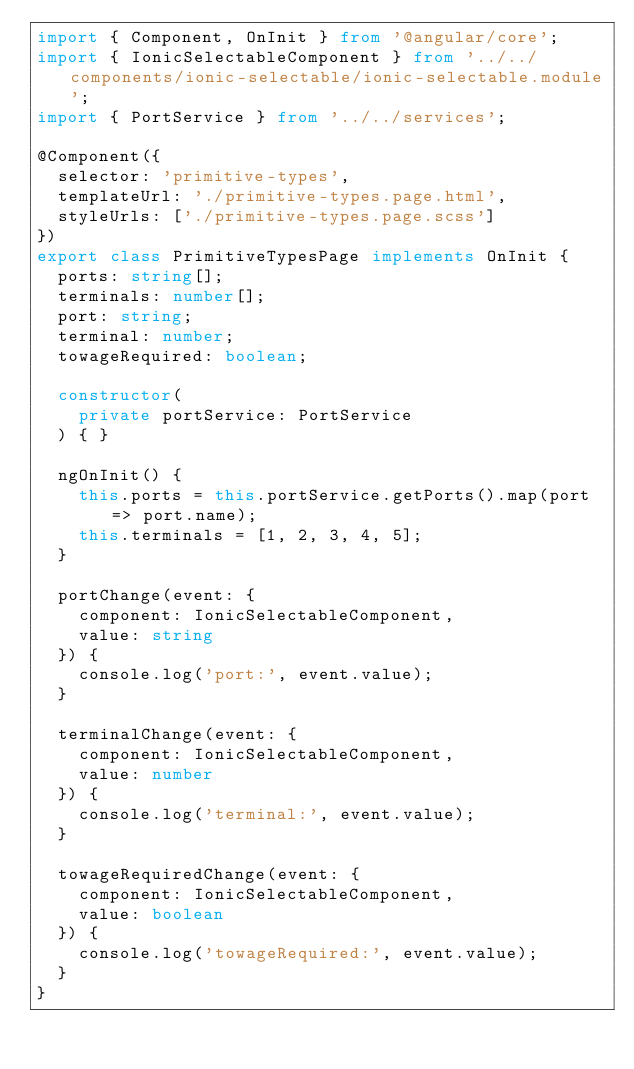<code> <loc_0><loc_0><loc_500><loc_500><_TypeScript_>import { Component, OnInit } from '@angular/core';
import { IonicSelectableComponent } from '../../components/ionic-selectable/ionic-selectable.module';
import { PortService } from '../../services';

@Component({
  selector: 'primitive-types',
  templateUrl: './primitive-types.page.html',
  styleUrls: ['./primitive-types.page.scss']
})
export class PrimitiveTypesPage implements OnInit {
  ports: string[];
  terminals: number[];
  port: string;
  terminal: number;
  towageRequired: boolean;

  constructor(
    private portService: PortService
  ) { }

  ngOnInit() {
    this.ports = this.portService.getPorts().map(port => port.name);
    this.terminals = [1, 2, 3, 4, 5];
  }

  portChange(event: {
    component: IonicSelectableComponent,
    value: string
  }) {
    console.log('port:', event.value);
  }

  terminalChange(event: {
    component: IonicSelectableComponent,
    value: number
  }) {
    console.log('terminal:', event.value);
  }

  towageRequiredChange(event: {
    component: IonicSelectableComponent,
    value: boolean
  }) {
    console.log('towageRequired:', event.value);
  }
}
</code> 